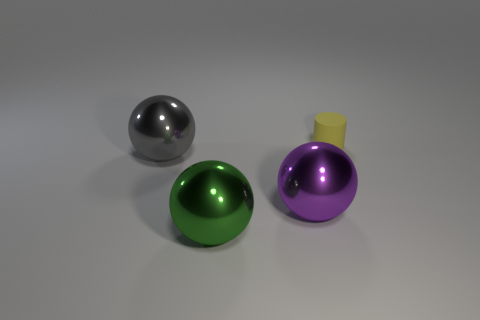Subtract all large green balls. How many balls are left? 2 Add 2 gray balls. How many objects exist? 6 Subtract all purple spheres. How many spheres are left? 2 Subtract all balls. How many objects are left? 1 Subtract 0 yellow cubes. How many objects are left? 4 Subtract all green spheres. Subtract all green blocks. How many spheres are left? 2 Subtract all large green metallic balls. Subtract all gray spheres. How many objects are left? 2 Add 4 large shiny spheres. How many large shiny spheres are left? 7 Add 2 purple objects. How many purple objects exist? 3 